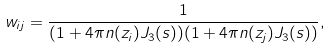<formula> <loc_0><loc_0><loc_500><loc_500>w _ { i j } = \frac { 1 } { ( 1 + 4 \pi n ( z _ { i } ) J _ { 3 } ( s ) ) ( 1 + 4 \pi n ( z _ { j } ) J _ { 3 } ( s ) ) } ,</formula> 